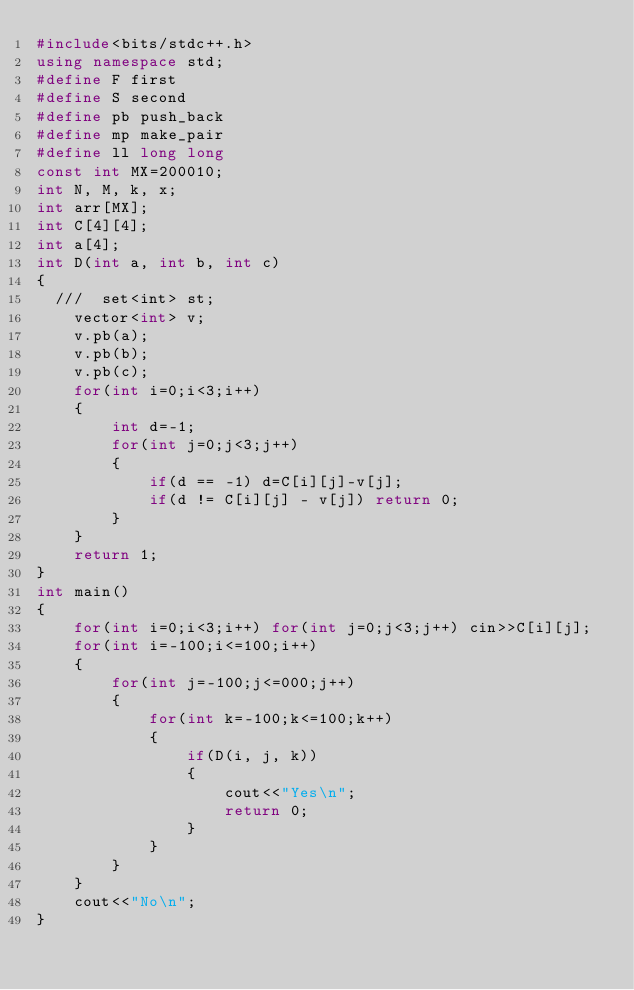<code> <loc_0><loc_0><loc_500><loc_500><_C++_>#include<bits/stdc++.h>
using namespace std;
#define F first
#define S second
#define pb push_back
#define mp make_pair
#define ll long long
const int MX=200010;
int N, M, k, x;
int arr[MX];
int C[4][4];
int a[4];
int D(int a, int b, int c)
{
  ///  set<int> st;
    vector<int> v;
    v.pb(a);
    v.pb(b);
    v.pb(c);
    for(int i=0;i<3;i++)
    {
        int d=-1;
        for(int j=0;j<3;j++)
        {
            if(d == -1) d=C[i][j]-v[j];
            if(d != C[i][j] - v[j]) return 0;
        }
    }
    return 1;
}
int main()
{
    for(int i=0;i<3;i++) for(int j=0;j<3;j++) cin>>C[i][j];
    for(int i=-100;i<=100;i++)
    {
        for(int j=-100;j<=000;j++)
        {
            for(int k=-100;k<=100;k++)
            {
                if(D(i, j, k))
                {
                    cout<<"Yes\n";
                    return 0;
                }
            }
        }
    }
    cout<<"No\n";
}
</code> 